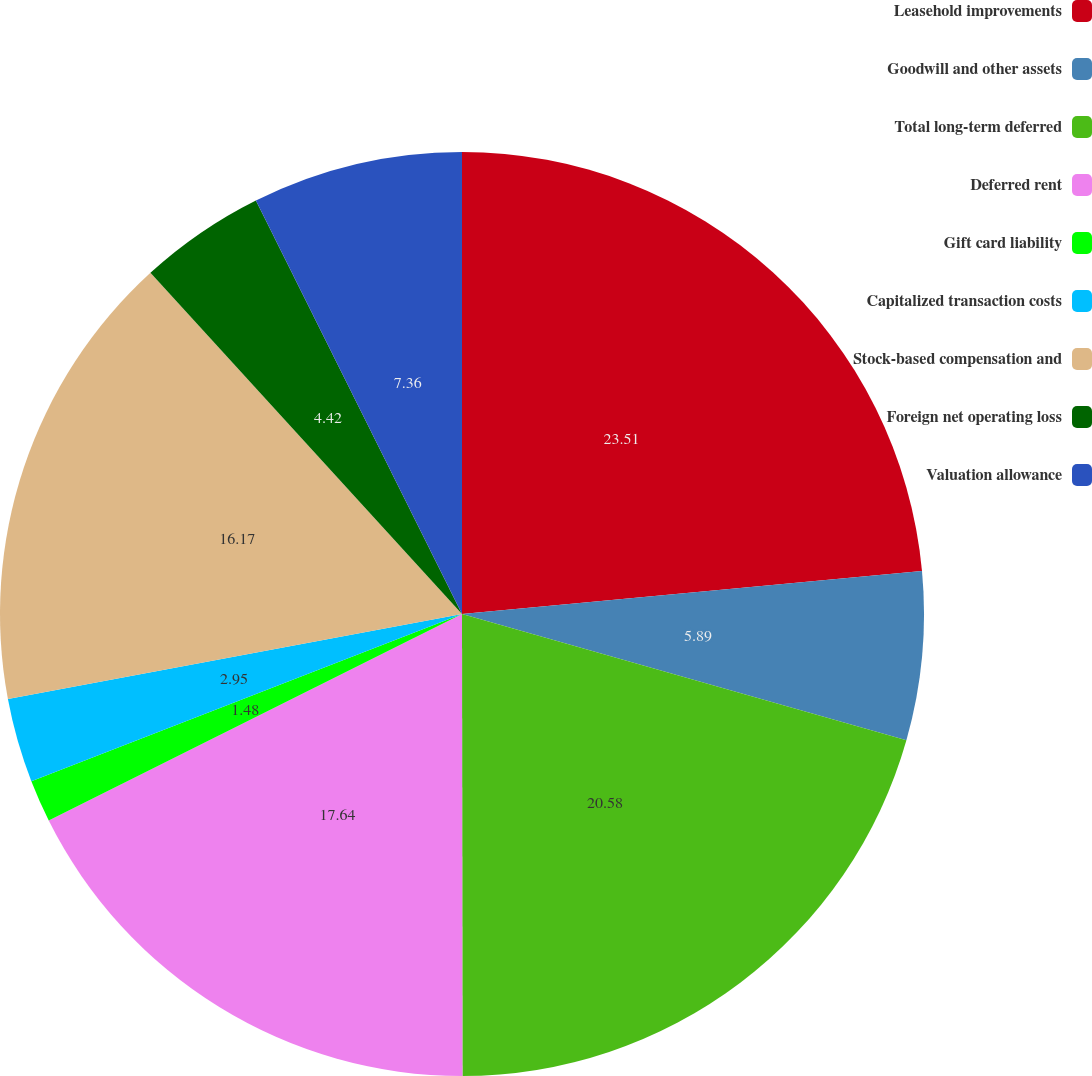Convert chart. <chart><loc_0><loc_0><loc_500><loc_500><pie_chart><fcel>Leasehold improvements<fcel>Goodwill and other assets<fcel>Total long-term deferred<fcel>Deferred rent<fcel>Gift card liability<fcel>Capitalized transaction costs<fcel>Stock-based compensation and<fcel>Foreign net operating loss<fcel>Valuation allowance<nl><fcel>23.52%<fcel>5.89%<fcel>20.58%<fcel>17.64%<fcel>1.48%<fcel>2.95%<fcel>16.17%<fcel>4.42%<fcel>7.36%<nl></chart> 